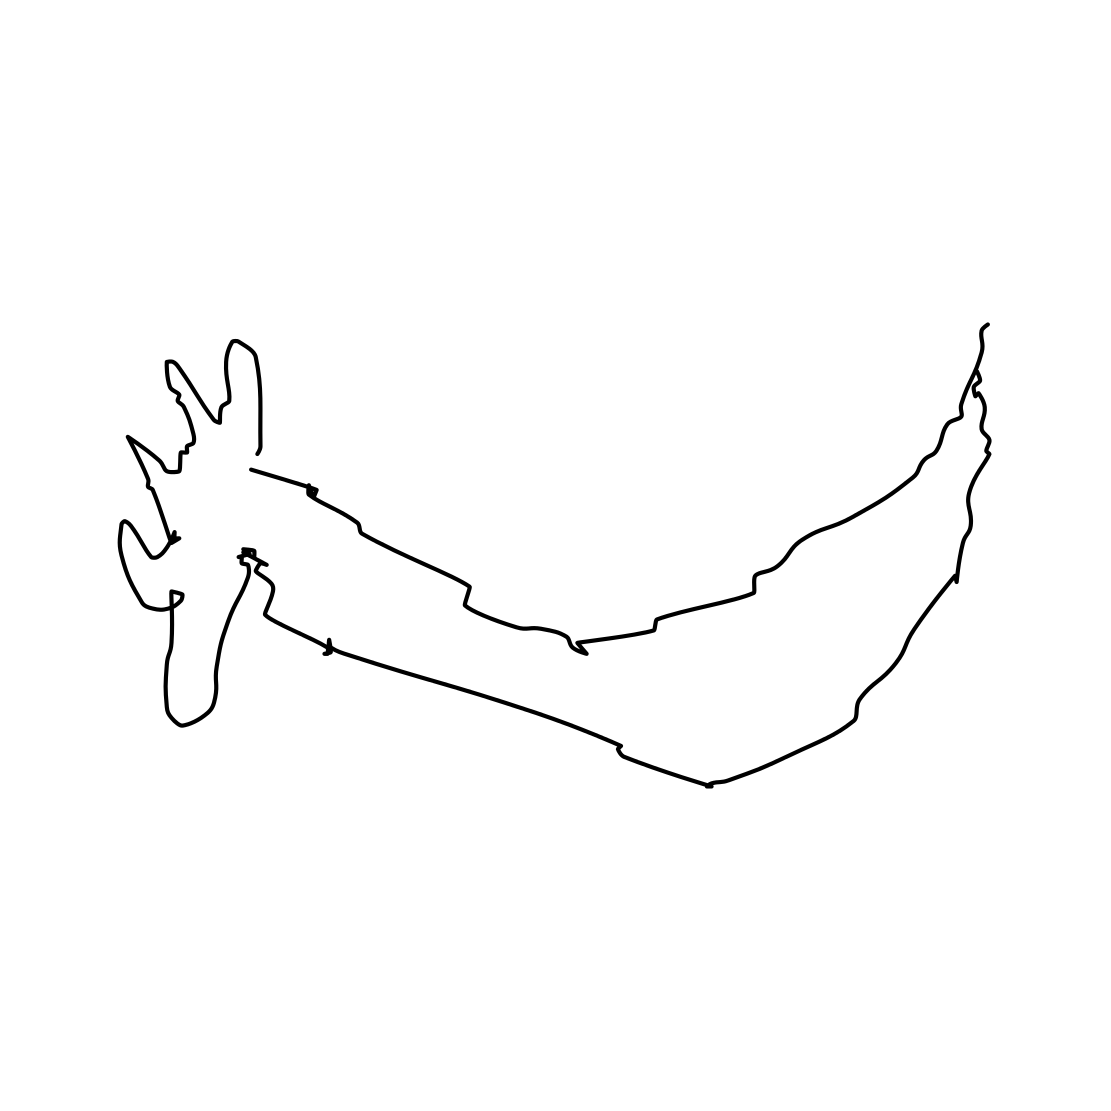Is this a motorbike in the image? No 